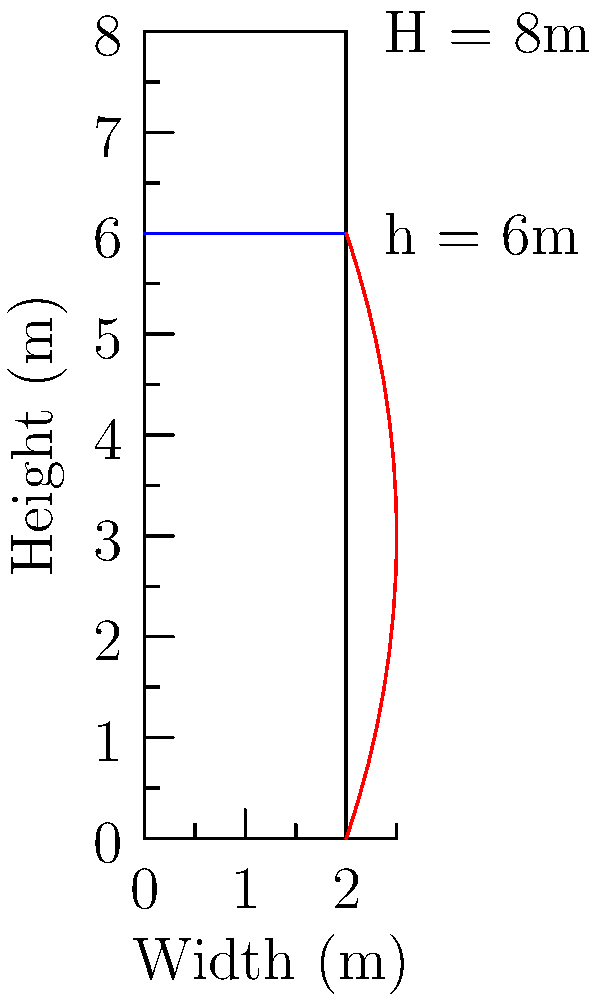In your latest role as a civil engineer in an action movie, you're tasked with calculating the water pressure distribution on a dam wall. The dam is 8 meters high, and the water level in the reservoir is 6 meters. Assuming the density of water is 1000 kg/m³ and gravitational acceleration is 9.81 m/s², determine the water pressure at the base of the dam wall. Express your answer in Pascals (Pa). To calculate the water pressure at the base of the dam wall, we'll use the following steps:

1. Recall the formula for hydrostatic pressure:
   $$P = \rho g h$$
   Where:
   $P$ = pressure (Pa)
   $\rho$ = density of water (1000 kg/m³)
   $g$ = gravitational acceleration (9.81 m/s²)
   $h$ = depth of water (6 m)

2. Substitute the given values into the equation:
   $$P = 1000 \text{ kg/m³} \times 9.81 \text{ m/s²} \times 6 \text{ m}$$

3. Calculate the result:
   $$P = 58,860 \text{ Pa}$$

4. Round to the nearest whole number:
   $$P \approx 58,860 \text{ Pa}$$

The water pressure at the base of the dam wall is approximately 58,860 Pa.
Answer: 58,860 Pa 